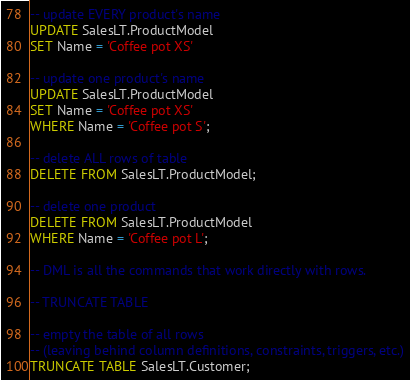<code> <loc_0><loc_0><loc_500><loc_500><_SQL_>
-- update EVERY product's name
UPDATE SalesLT.ProductModel
SET Name = 'Coffee pot XS'

-- update one product's name
UPDATE SalesLT.ProductModel
SET Name = 'Coffee pot XS'
WHERE Name = 'Coffee pot S';

-- delete ALL rows of table
DELETE FROM SalesLT.ProductModel;

-- delete one product
DELETE FROM SalesLT.ProductModel
WHERE Name = 'Coffee pot L';

-- DML is all the commands that work directly with rows.

-- TRUNCATE TABLE

-- empty the table of all rows
-- (leaving behind column definitions, constraints, triggers, etc.)
TRUNCATE TABLE SalesLT.Customer;

</code> 